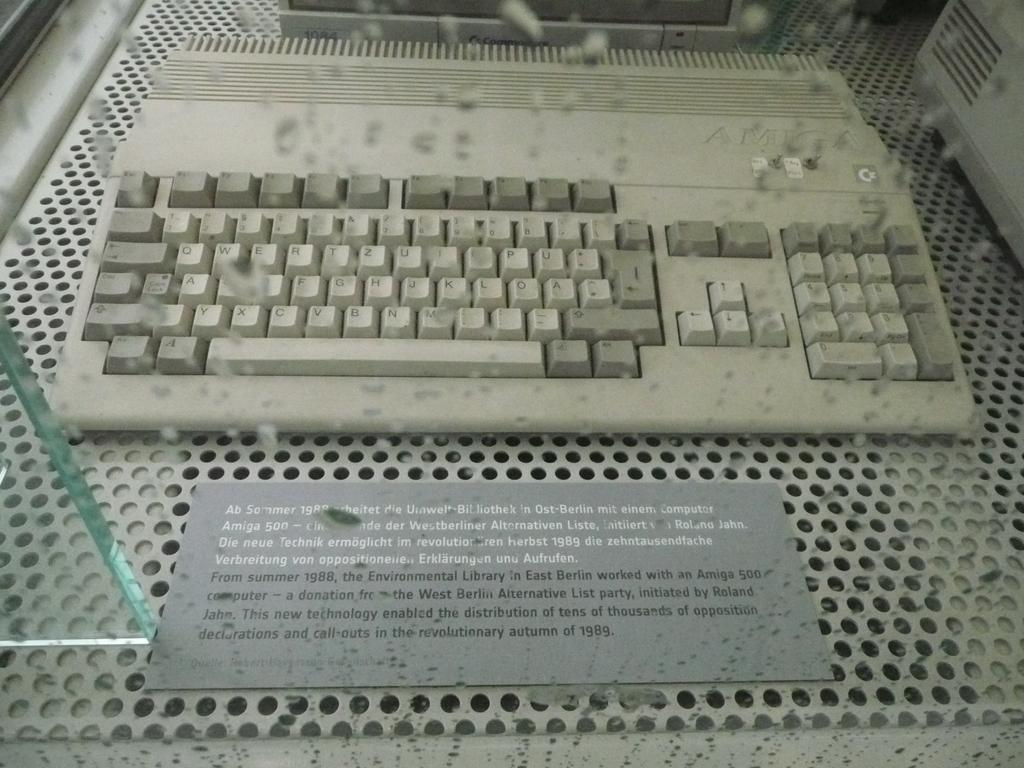Provide a one-sentence caption for the provided image. A keyboard sits behind a placard that begins with the words, "Ab Sommer 1988.". 